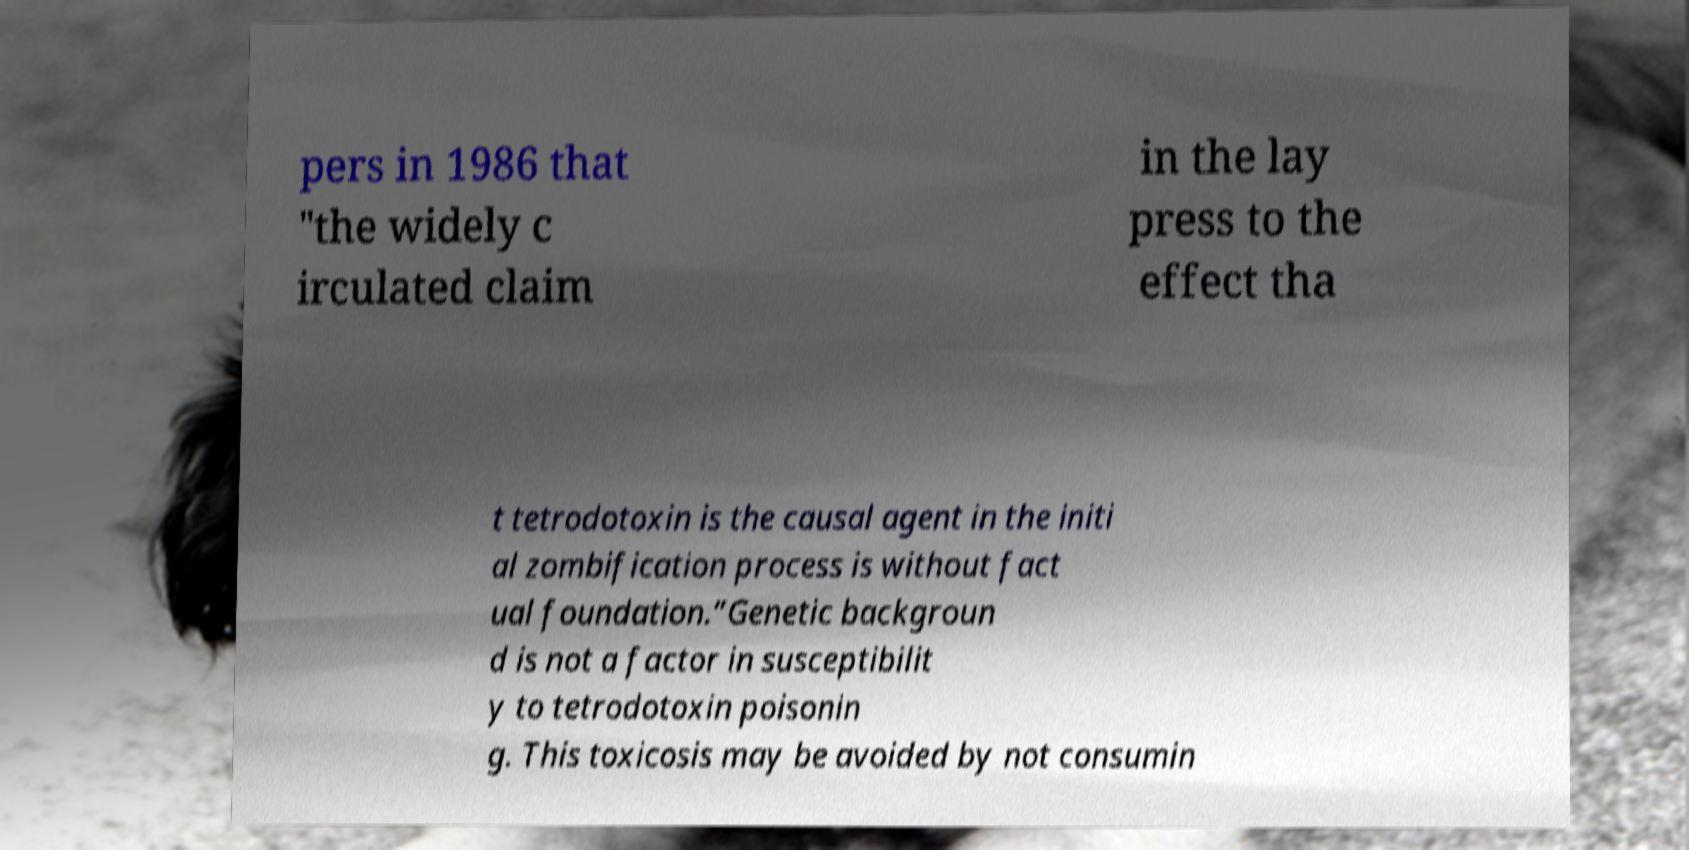There's text embedded in this image that I need extracted. Can you transcribe it verbatim? pers in 1986 that "the widely c irculated claim in the lay press to the effect tha t tetrodotoxin is the causal agent in the initi al zombification process is without fact ual foundation.”Genetic backgroun d is not a factor in susceptibilit y to tetrodotoxin poisonin g. This toxicosis may be avoided by not consumin 